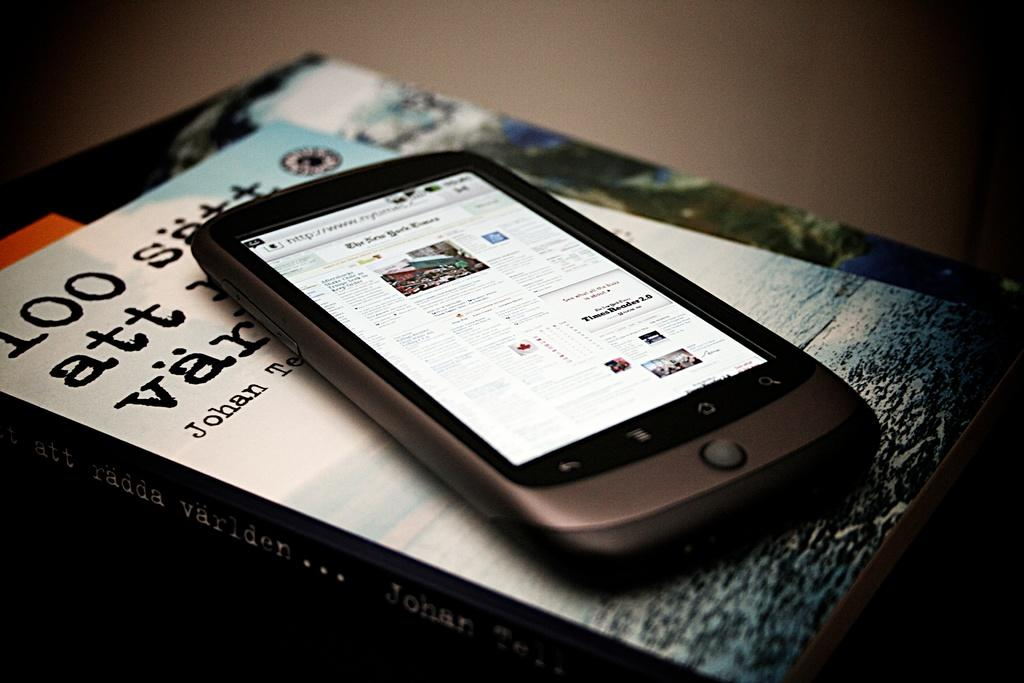<image>
Create a compact narrative representing the image presented. A black cell phone displaying a New York Times page sitting on top of a book 